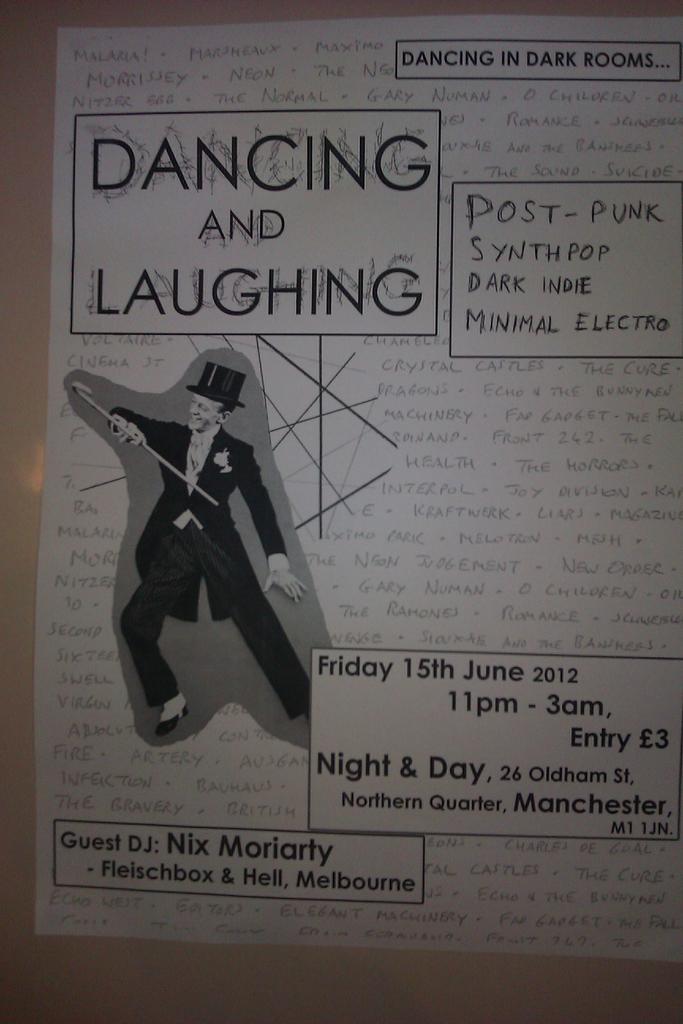Is this a magazine?
Keep it short and to the point. No. What date is this event?
Your response must be concise. June 15 2012. 